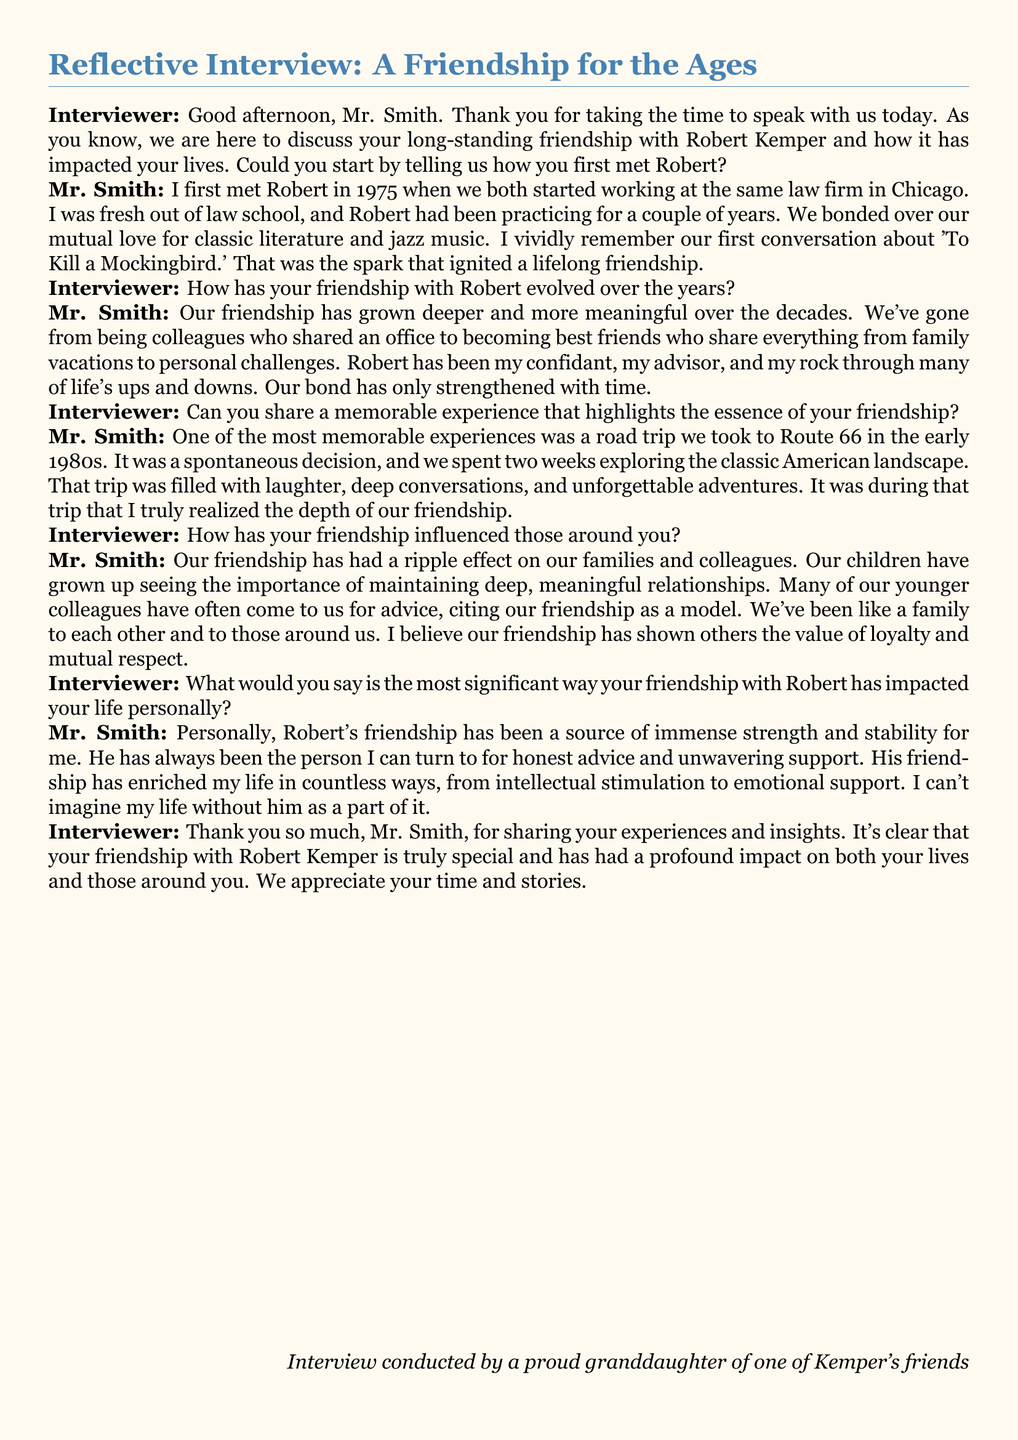How did Mr. Smith first meet Robert Kemper? Mr. Smith first met Robert in 1975 when they both started working at the same law firm in Chicago.
Answer: 1975 What was the shared interest that sparked their friendship? Mr. Smith and Robert bonded over their mutual love for classic literature and jazz music.
Answer: Classic literature and jazz music What was one memorable experience highlighted in the interview? One of the most memorable experiences was a road trip they took to Route 66 in the early 1980s.
Answer: Road trip to Route 66 How has their friendship influenced their families? Their friendship has shown their children the importance of maintaining deep, meaningful relationships.
Answer: Importance of deep relationships What is the most significant personal impact of Robert's friendship on Mr. Smith? Robert's friendship has been a source of immense strength and stability for him.
Answer: Strength and stability What year did the road trip to Route 66 take place? The road trip occurred in the early 1980s.
Answer: Early 1980s What type of document is this transcript? The document is an interview transcript.
Answer: Interview transcript Who conducted the interview? The interview was conducted by a proud granddaughter of one of Kemper's friends.
Answer: A proud granddaughter of one of Kemper's friends What type of advice do younger colleagues seek from Mr. Smith and Robert? Younger colleagues often come to them for life advice, citing their friendship as a model.
Answer: Life advice 